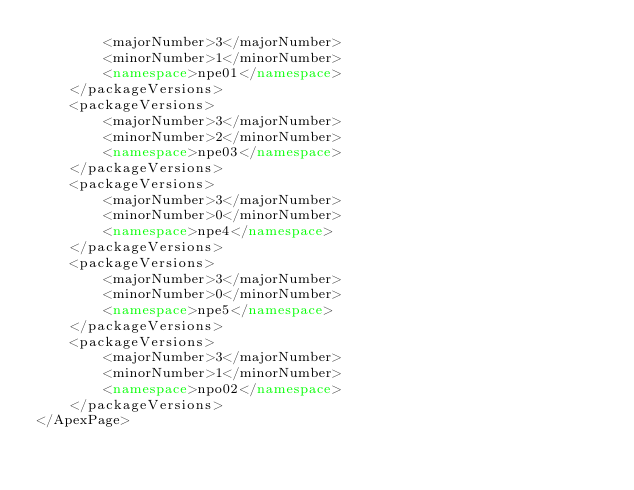<code> <loc_0><loc_0><loc_500><loc_500><_XML_>        <majorNumber>3</majorNumber>
        <minorNumber>1</minorNumber>
        <namespace>npe01</namespace>
    </packageVersions>
    <packageVersions>
        <majorNumber>3</majorNumber>
        <minorNumber>2</minorNumber>
        <namespace>npe03</namespace>
    </packageVersions>
    <packageVersions>
        <majorNumber>3</majorNumber>
        <minorNumber>0</minorNumber>
        <namespace>npe4</namespace>
    </packageVersions>
    <packageVersions>
        <majorNumber>3</majorNumber>
        <minorNumber>0</minorNumber>
        <namespace>npe5</namespace>
    </packageVersions>
    <packageVersions>
        <majorNumber>3</majorNumber>
        <minorNumber>1</minorNumber>
        <namespace>npo02</namespace>
    </packageVersions>
</ApexPage>
</code> 